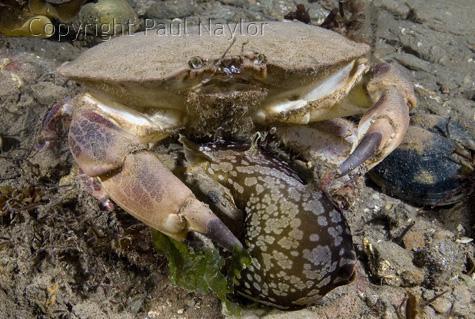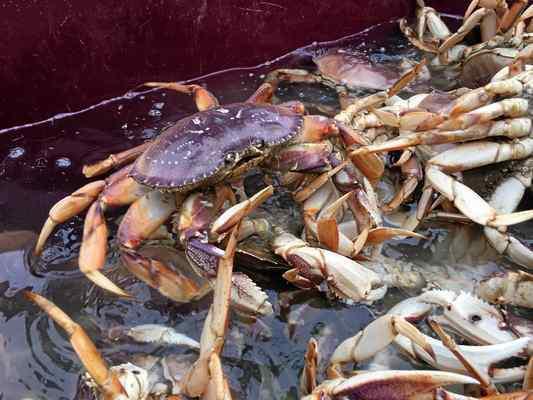The first image is the image on the left, the second image is the image on the right. For the images shown, is this caption "IN at least one image there is at least one blue clawed crab sitting on a wooden dock." true? Answer yes or no. No. The first image is the image on the left, the second image is the image on the right. For the images shown, is this caption "The left image contains one forward-facing crab with its top shell visible, and the right image contains a mass of crabs." true? Answer yes or no. Yes. 